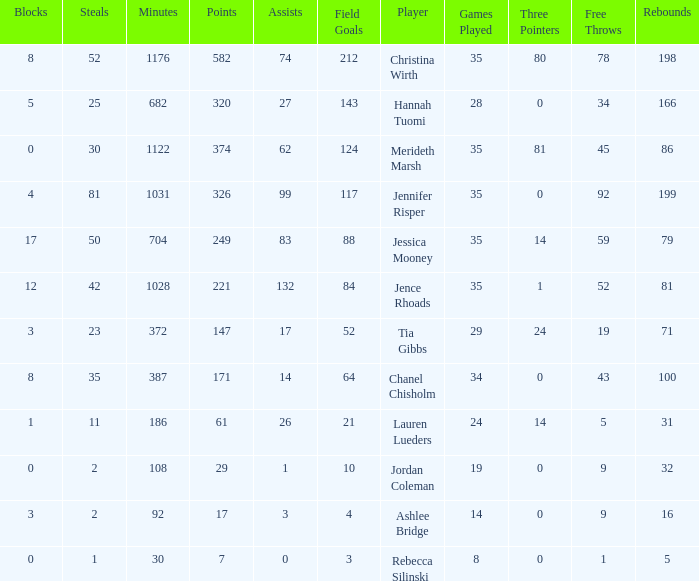For how long did Jordan Coleman play? 108.0. 